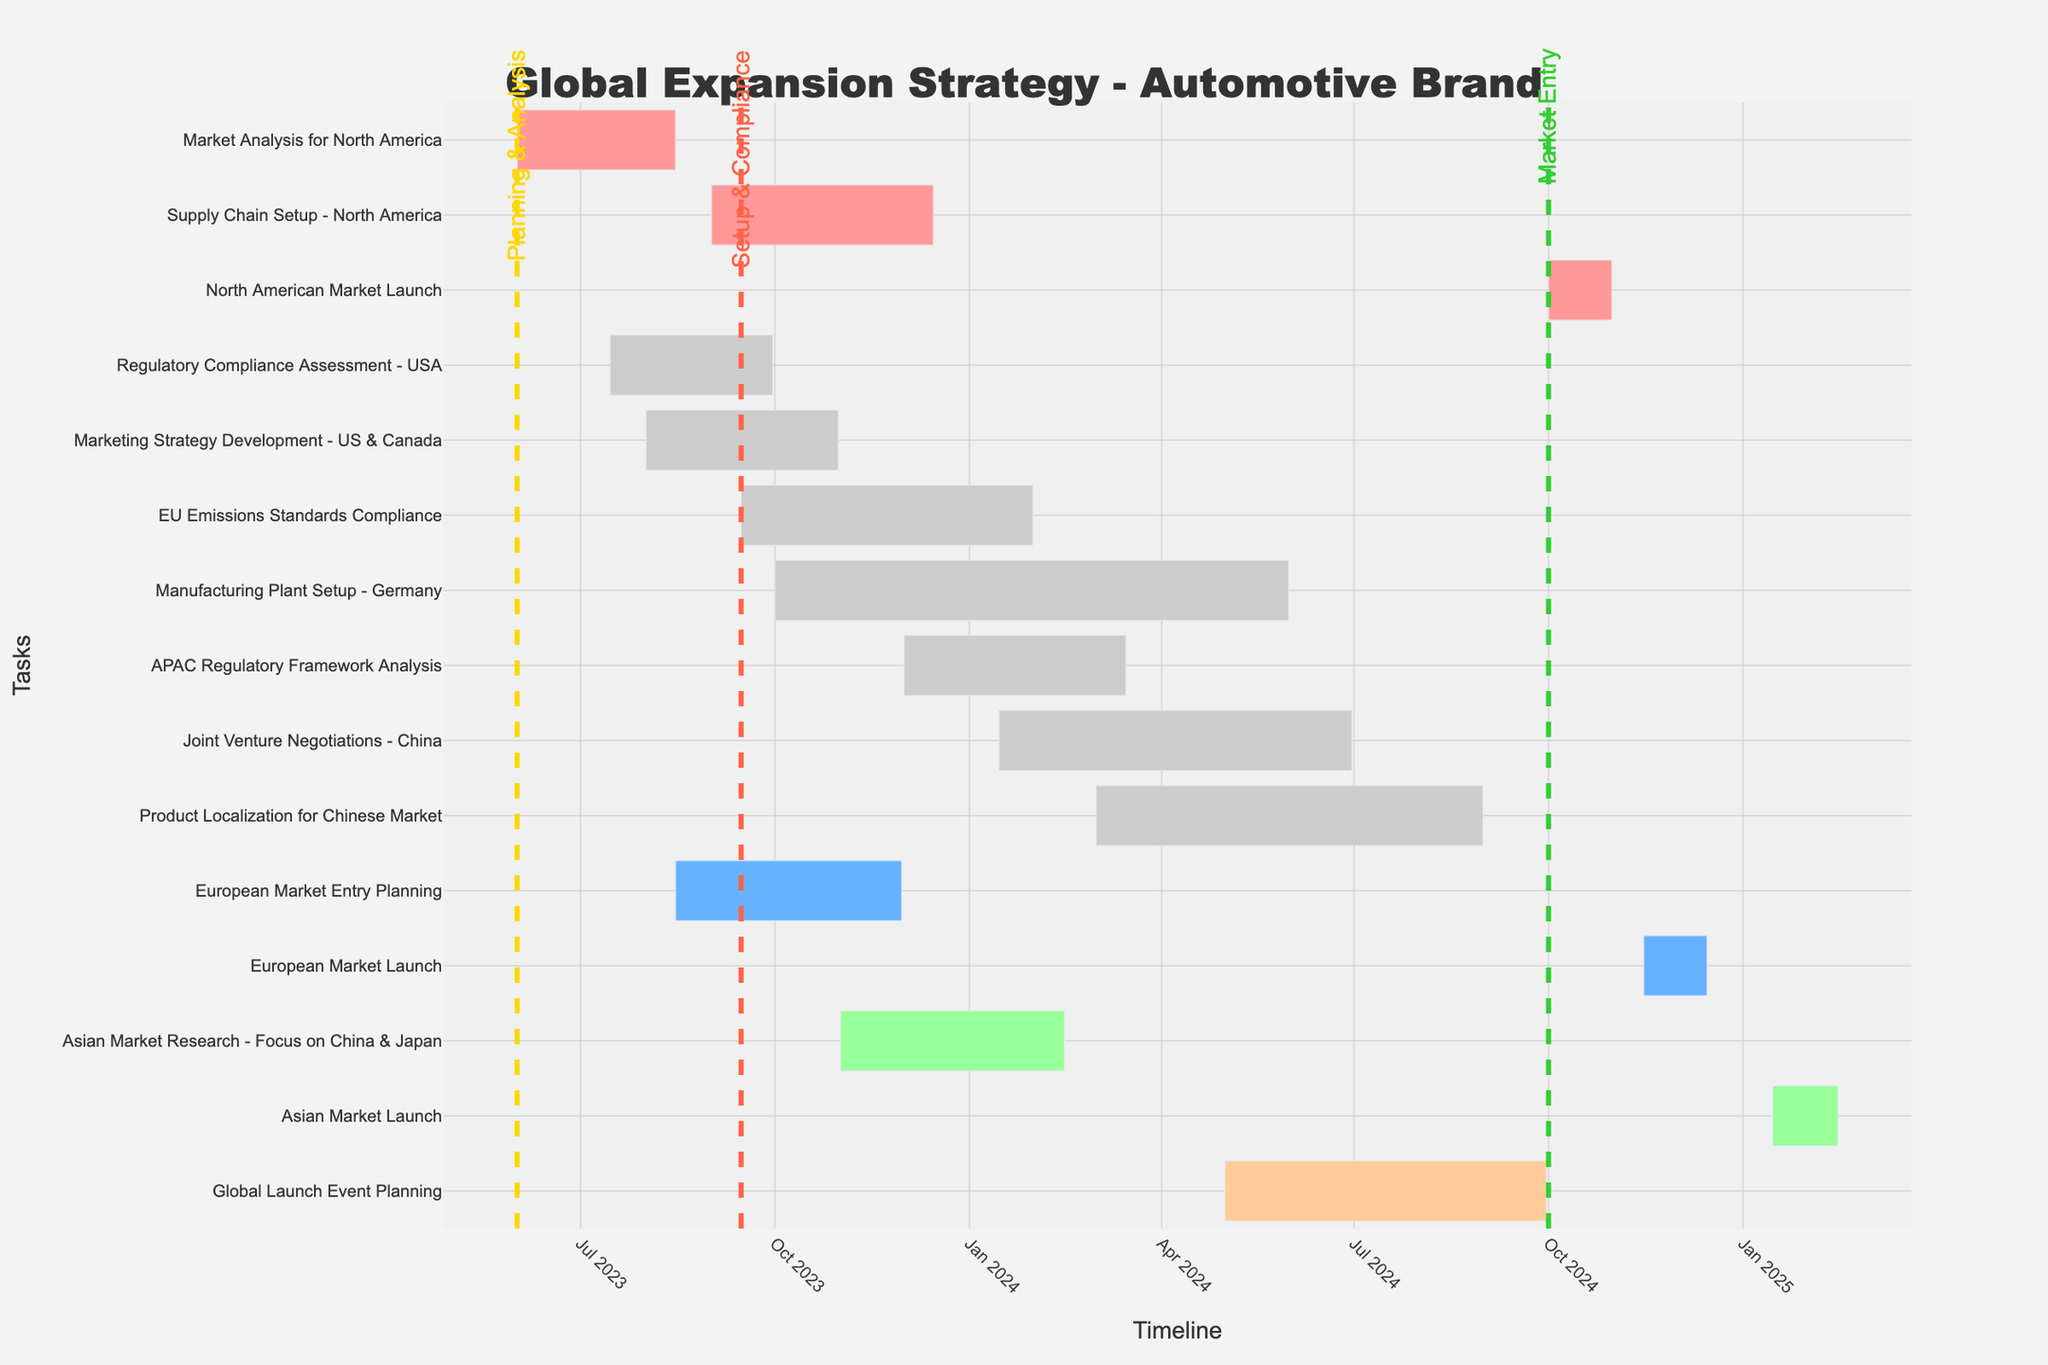How long does the Market Analysis for North America take? The Market Analysis for North America starts on 2023-06-01 and ends on 2023-08-15. The duration is also provided as 75 days.
Answer: 75 days Which task has the longest duration, and how many days does it take? The Manufacturing Plant Setup in Germany has the longest duration, starting on 2023-10-01 and ending on 2024-05-31, lasting 243 days.
Answer: Manufacturing Plant Setup - Germany, 243 days What are the start and end dates for the European Market Entry Planning phase? The European Market Entry Planning starts on 2023-08-15 and ends on 2023-11-30 as shown in the timeline.
Answer: 2023-08-15 to 2023-11-30 Compare the durations of Marketing Strategy Development for the US & Canada and Supply Chain Setup for North America. Which one is longer and by how many days? Marketing Strategy Development for the US & Canada lasts 91 days, whereas Supply Chain Setup for North America takes 105 days. The difference between their durations is 105 - 91 = 14 days.
Answer: Supply Chain Setup - North America, 14 days longer How many tasks are scheduled to end in the first quarter of 2024? Tasks that end in the first quarter of 2024 include EU Emissions Standards Compliance (2024-01-31), and Asian Market Research - Focus on China & Japan (2024-02-15). There are 2 such tasks.
Answer: 2 tasks Which phase separator appears first in the timeline? The first phase separator appears on 2023-06-01, labeled "Planning & Analysis" in yellow.
Answer: Planning & Analysis What tasks are being executed concurrently during October 2023? In October 2023, the concurrent tasks are Marketing Strategy Development - US & Canada, Supply Chain Setup - North America, European Market Entry Planning, and the start of Manufacturing Plant Setup - Germany.
Answer: 4 tasks How much time is there between the completion of the North American Market Launch and the start of the European Market Launch? The North American Market Launch ends on 2024-10-31, and the European Market Launch starts on 2024-11-15. The time gap is 15 days.
Answer: 15 days Which region has the most tasks and how many are there? North America has the most tasks, which include Market Analysis, Regulatory Compliance Assessment, Marketing Strategy Development, Supply Chain Setup, and North American Market Launch, totaling 5 tasks.
Answer: 5 tasks (North America) What is the total duration for the APAC Regulatory Framework Analysis task? The APAC Regulatory Framework Analysis starts on 2023-12-01 and ends on 2024-03-15. The duration provided is 105 days.
Answer: 105 days 